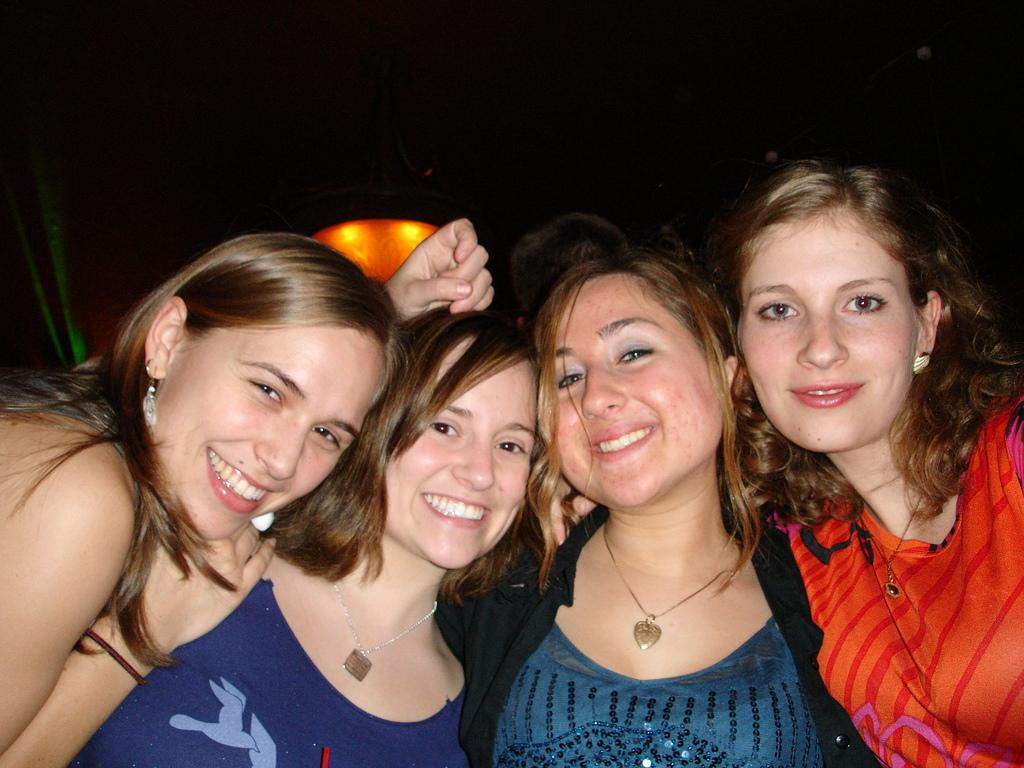How many people are in the foreground of the image? There are four women in the foreground of the image. What are the women doing in the image? The women are posing for a camera. What is the facial expression of the women in the image? The women are smiling. What can be observed about the background of the image? The background of the image is dark. What type of canvas is being used for the discussion in the image? There is no canvas or discussion present in the image; it features four women posing for a camera. 